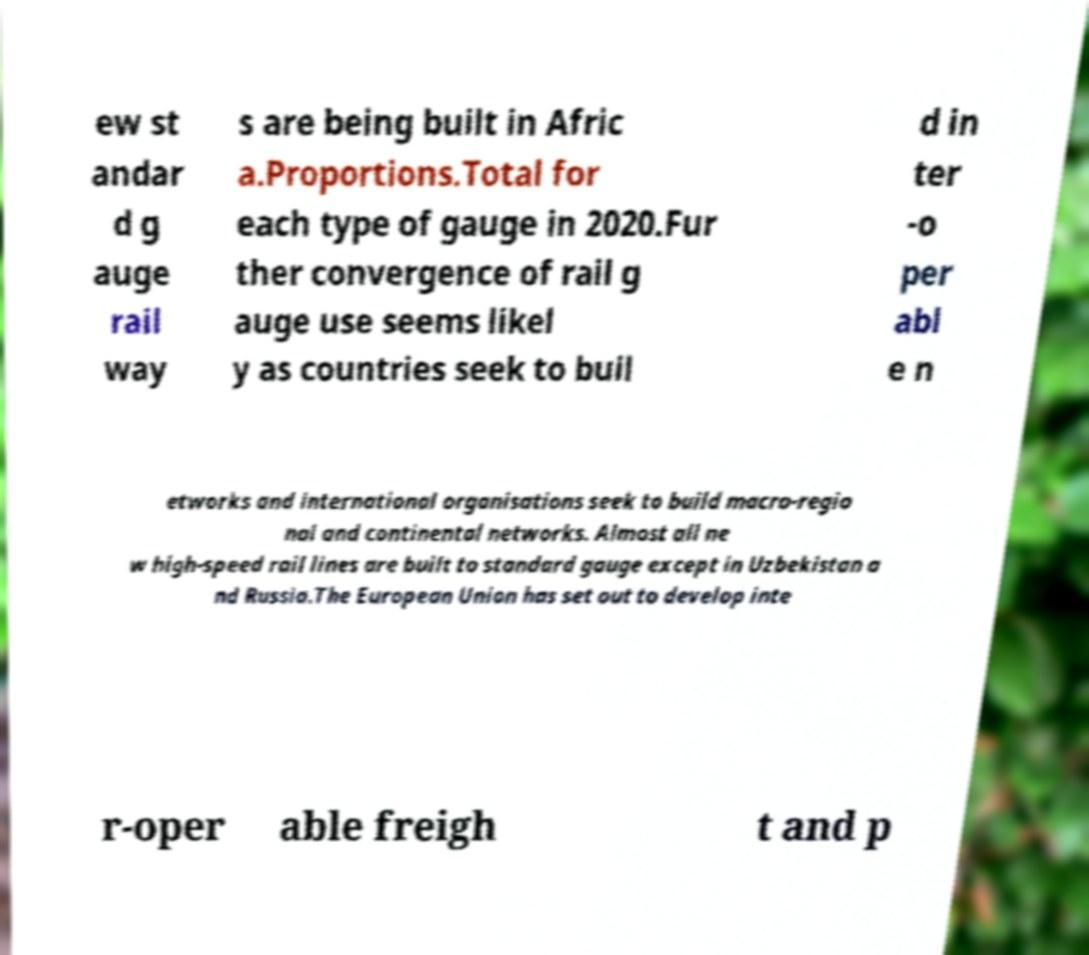For documentation purposes, I need the text within this image transcribed. Could you provide that? ew st andar d g auge rail way s are being built in Afric a.Proportions.Total for each type of gauge in 2020.Fur ther convergence of rail g auge use seems likel y as countries seek to buil d in ter -o per abl e n etworks and international organisations seek to build macro-regio nal and continental networks. Almost all ne w high-speed rail lines are built to standard gauge except in Uzbekistan a nd Russia.The European Union has set out to develop inte r-oper able freigh t and p 